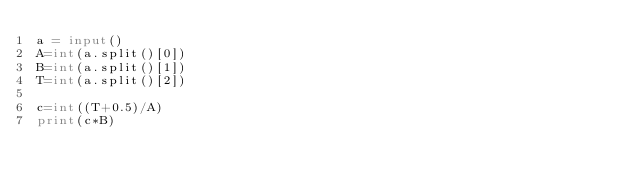Convert code to text. <code><loc_0><loc_0><loc_500><loc_500><_Python_>a = input()
A=int(a.split()[0])
B=int(a.split()[1])
T=int(a.split()[2])

c=int((T+0.5)/A)
print(c*B)</code> 